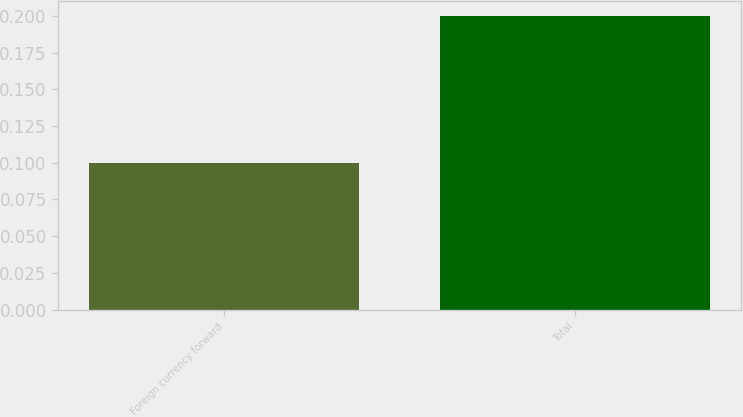Convert chart. <chart><loc_0><loc_0><loc_500><loc_500><bar_chart><fcel>Foreign currency forward<fcel>Total<nl><fcel>0.1<fcel>0.2<nl></chart> 